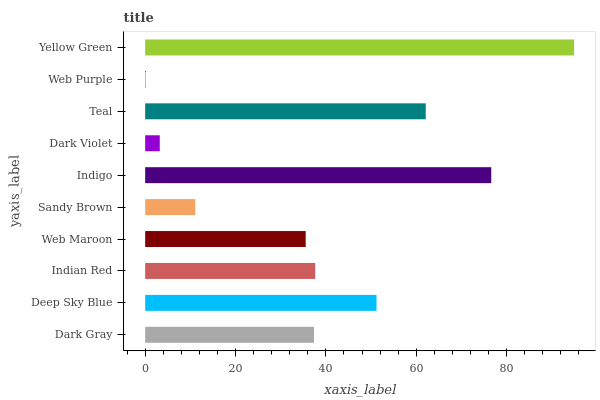Is Web Purple the minimum?
Answer yes or no. Yes. Is Yellow Green the maximum?
Answer yes or no. Yes. Is Deep Sky Blue the minimum?
Answer yes or no. No. Is Deep Sky Blue the maximum?
Answer yes or no. No. Is Deep Sky Blue greater than Dark Gray?
Answer yes or no. Yes. Is Dark Gray less than Deep Sky Blue?
Answer yes or no. Yes. Is Dark Gray greater than Deep Sky Blue?
Answer yes or no. No. Is Deep Sky Blue less than Dark Gray?
Answer yes or no. No. Is Indian Red the high median?
Answer yes or no. Yes. Is Dark Gray the low median?
Answer yes or no. Yes. Is Deep Sky Blue the high median?
Answer yes or no. No. Is Teal the low median?
Answer yes or no. No. 